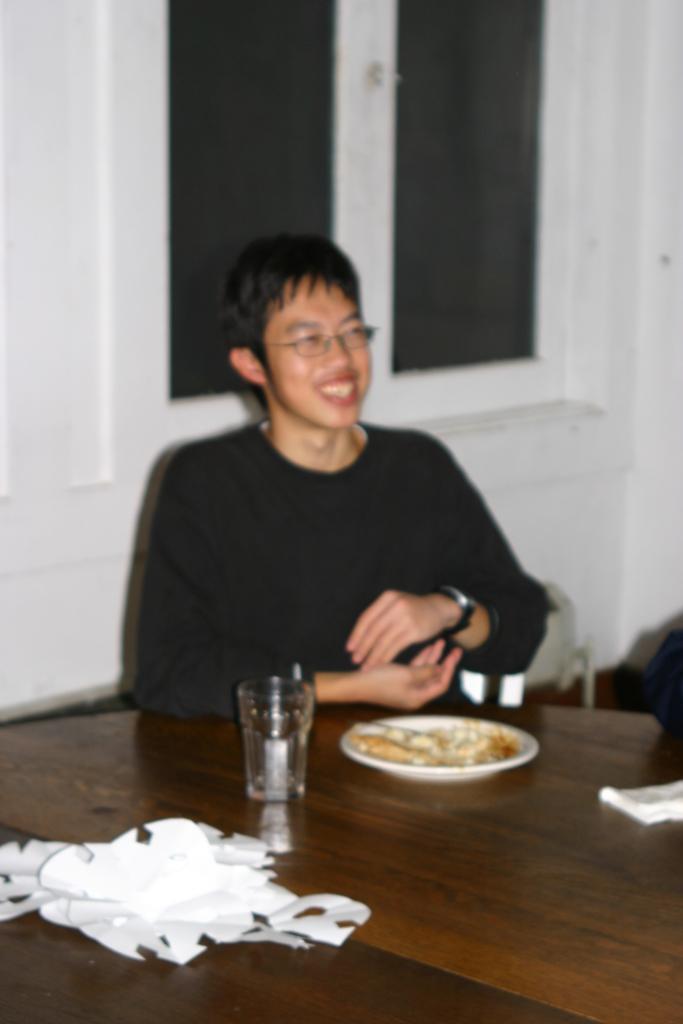Can you describe this image briefly? In the foreground of this image, there is a man in black dress sitting near table having plate, glass,and papers on the table. In the background, there is a white wall and a window. 